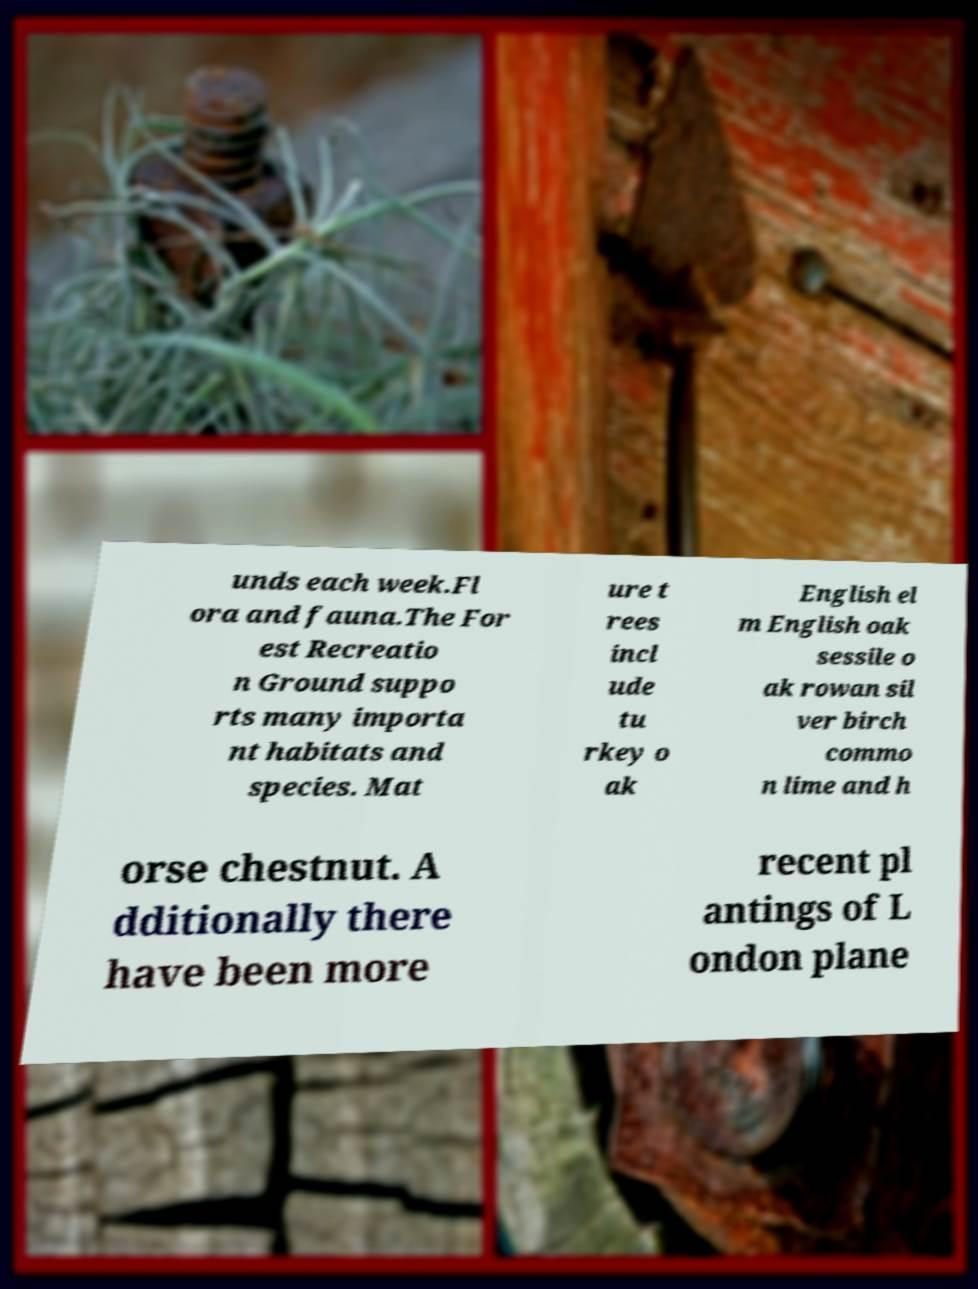Could you assist in decoding the text presented in this image and type it out clearly? unds each week.Fl ora and fauna.The For est Recreatio n Ground suppo rts many importa nt habitats and species. Mat ure t rees incl ude tu rkey o ak English el m English oak sessile o ak rowan sil ver birch commo n lime and h orse chestnut. A dditionally there have been more recent pl antings of L ondon plane 